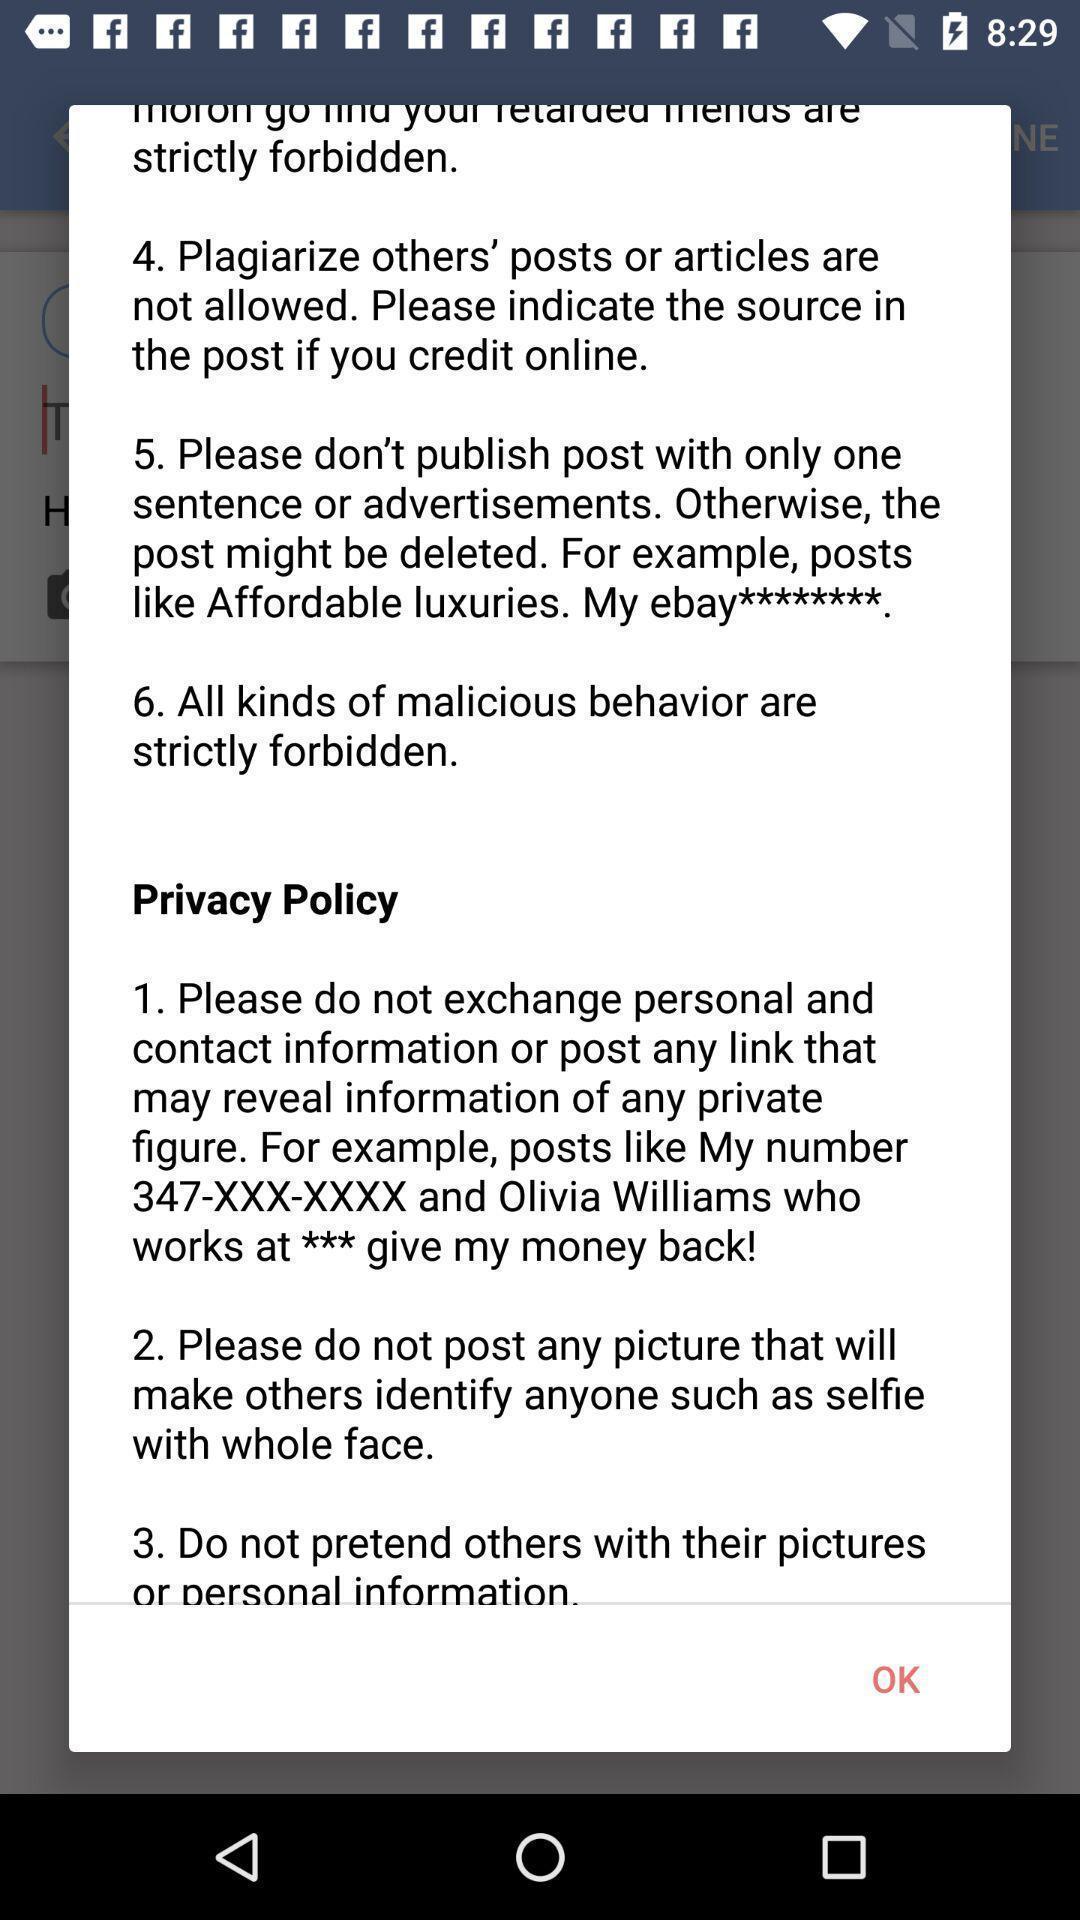Give me a summary of this screen capture. Popup showing privacy policy. 